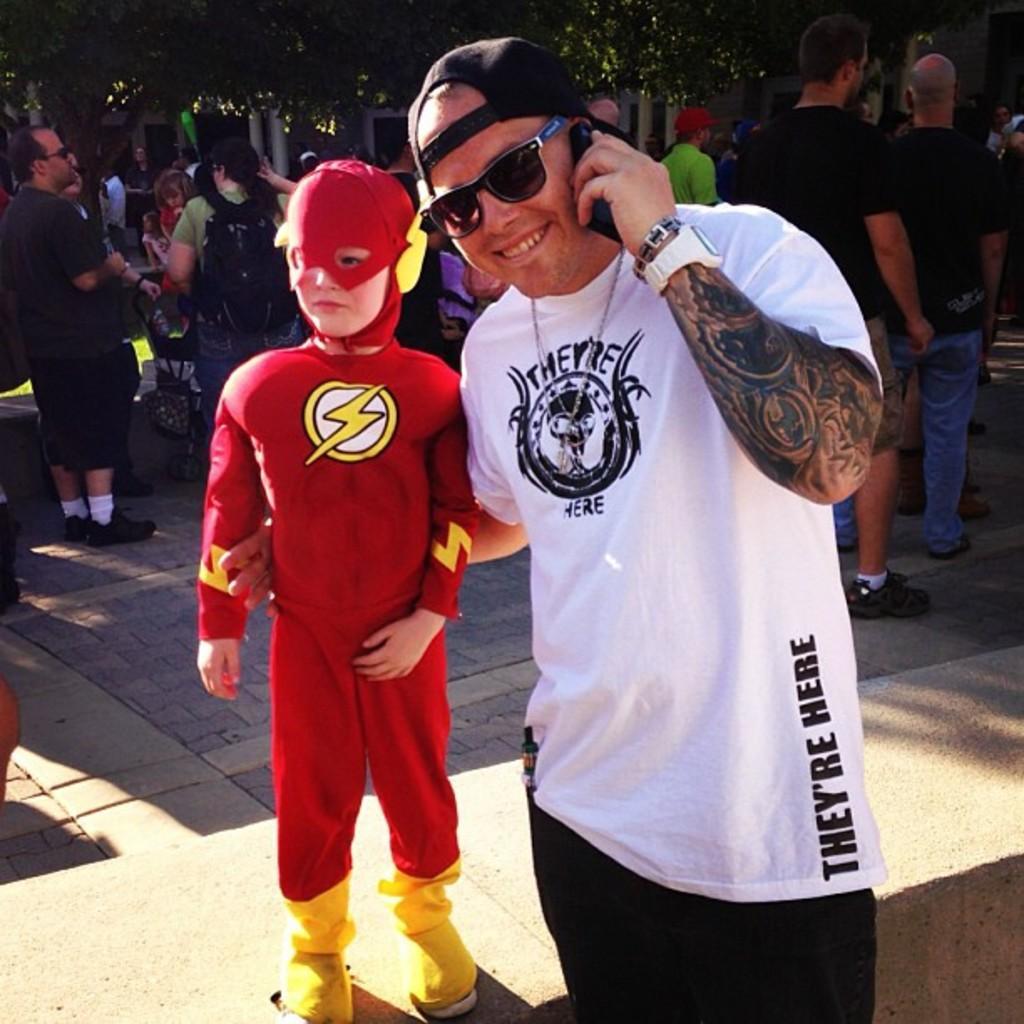Describe this image in one or two sentences. In this picture I can see two persons standing, a person in a fancy dress, there are group of people standing, and in the background there are trees. 